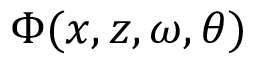Convert formula to latex. <formula><loc_0><loc_0><loc_500><loc_500>\Phi ( x , z , \omega , \theta )</formula> 